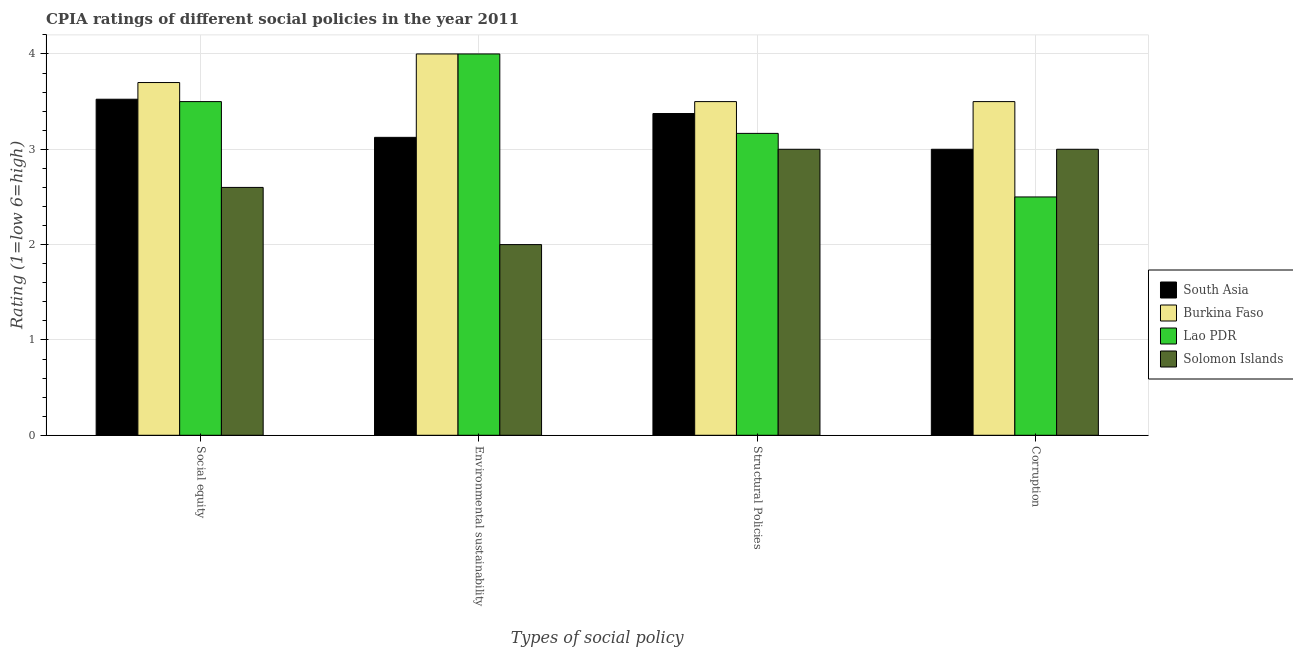How many different coloured bars are there?
Offer a terse response. 4. How many groups of bars are there?
Offer a terse response. 4. What is the label of the 2nd group of bars from the left?
Your response must be concise. Environmental sustainability. What is the cpia rating of structural policies in Lao PDR?
Ensure brevity in your answer.  3.17. Across all countries, what is the minimum cpia rating of environmental sustainability?
Your answer should be very brief. 2. In which country was the cpia rating of structural policies maximum?
Keep it short and to the point. Burkina Faso. In which country was the cpia rating of structural policies minimum?
Keep it short and to the point. Solomon Islands. What is the total cpia rating of social equity in the graph?
Provide a succinct answer. 13.32. What is the difference between the cpia rating of social equity in Lao PDR and that in Solomon Islands?
Give a very brief answer. 0.9. What is the difference between the cpia rating of environmental sustainability in Solomon Islands and the cpia rating of structural policies in South Asia?
Make the answer very short. -1.38. What is the average cpia rating of environmental sustainability per country?
Make the answer very short. 3.28. What is the difference between the cpia rating of environmental sustainability and cpia rating of corruption in Solomon Islands?
Offer a very short reply. -1. In how many countries, is the cpia rating of structural policies greater than 2.6 ?
Keep it short and to the point. 4. What is the ratio of the cpia rating of structural policies in Lao PDR to that in South Asia?
Provide a succinct answer. 0.94. Is the cpia rating of environmental sustainability in Lao PDR less than that in Solomon Islands?
Your answer should be very brief. No. What is the difference between the highest and the second highest cpia rating of social equity?
Your answer should be compact. 0.18. In how many countries, is the cpia rating of structural policies greater than the average cpia rating of structural policies taken over all countries?
Offer a terse response. 2. What does the 4th bar from the left in Environmental sustainability represents?
Your answer should be compact. Solomon Islands. What does the 4th bar from the right in Environmental sustainability represents?
Make the answer very short. South Asia. Are all the bars in the graph horizontal?
Give a very brief answer. No. What is the difference between two consecutive major ticks on the Y-axis?
Keep it short and to the point. 1. Where does the legend appear in the graph?
Your response must be concise. Center right. How many legend labels are there?
Offer a terse response. 4. What is the title of the graph?
Your answer should be compact. CPIA ratings of different social policies in the year 2011. What is the label or title of the X-axis?
Your response must be concise. Types of social policy. What is the label or title of the Y-axis?
Offer a very short reply. Rating (1=low 6=high). What is the Rating (1=low 6=high) of South Asia in Social equity?
Your response must be concise. 3.52. What is the Rating (1=low 6=high) in Burkina Faso in Social equity?
Ensure brevity in your answer.  3.7. What is the Rating (1=low 6=high) in Solomon Islands in Social equity?
Offer a very short reply. 2.6. What is the Rating (1=low 6=high) of South Asia in Environmental sustainability?
Your answer should be very brief. 3.12. What is the Rating (1=low 6=high) of South Asia in Structural Policies?
Ensure brevity in your answer.  3.38. What is the Rating (1=low 6=high) of Burkina Faso in Structural Policies?
Make the answer very short. 3.5. What is the Rating (1=low 6=high) of Lao PDR in Structural Policies?
Provide a short and direct response. 3.17. What is the Rating (1=low 6=high) of Burkina Faso in Corruption?
Your answer should be very brief. 3.5. What is the Rating (1=low 6=high) in Solomon Islands in Corruption?
Provide a succinct answer. 3. Across all Types of social policy, what is the maximum Rating (1=low 6=high) in South Asia?
Offer a terse response. 3.52. Across all Types of social policy, what is the maximum Rating (1=low 6=high) of Solomon Islands?
Your answer should be compact. 3. Across all Types of social policy, what is the minimum Rating (1=low 6=high) of Lao PDR?
Ensure brevity in your answer.  2.5. Across all Types of social policy, what is the minimum Rating (1=low 6=high) of Solomon Islands?
Keep it short and to the point. 2. What is the total Rating (1=low 6=high) in South Asia in the graph?
Provide a succinct answer. 13.03. What is the total Rating (1=low 6=high) in Lao PDR in the graph?
Your response must be concise. 13.17. What is the total Rating (1=low 6=high) of Solomon Islands in the graph?
Provide a short and direct response. 10.6. What is the difference between the Rating (1=low 6=high) in Burkina Faso in Social equity and that in Environmental sustainability?
Offer a very short reply. -0.3. What is the difference between the Rating (1=low 6=high) in South Asia in Social equity and that in Structural Policies?
Your response must be concise. 0.15. What is the difference between the Rating (1=low 6=high) of Solomon Islands in Social equity and that in Structural Policies?
Give a very brief answer. -0.4. What is the difference between the Rating (1=low 6=high) in South Asia in Social equity and that in Corruption?
Provide a succinct answer. 0.53. What is the difference between the Rating (1=low 6=high) of Lao PDR in Social equity and that in Corruption?
Provide a succinct answer. 1. What is the difference between the Rating (1=low 6=high) of Solomon Islands in Social equity and that in Corruption?
Ensure brevity in your answer.  -0.4. What is the difference between the Rating (1=low 6=high) in Burkina Faso in Environmental sustainability and that in Structural Policies?
Offer a terse response. 0.5. What is the difference between the Rating (1=low 6=high) of Lao PDR in Environmental sustainability and that in Structural Policies?
Provide a short and direct response. 0.83. What is the difference between the Rating (1=low 6=high) of South Asia in Environmental sustainability and that in Corruption?
Provide a succinct answer. 0.12. What is the difference between the Rating (1=low 6=high) of Burkina Faso in Environmental sustainability and that in Corruption?
Provide a short and direct response. 0.5. What is the difference between the Rating (1=low 6=high) of Solomon Islands in Environmental sustainability and that in Corruption?
Offer a terse response. -1. What is the difference between the Rating (1=low 6=high) of South Asia in Structural Policies and that in Corruption?
Provide a short and direct response. 0.38. What is the difference between the Rating (1=low 6=high) in Burkina Faso in Structural Policies and that in Corruption?
Ensure brevity in your answer.  0. What is the difference between the Rating (1=low 6=high) in Solomon Islands in Structural Policies and that in Corruption?
Your answer should be very brief. 0. What is the difference between the Rating (1=low 6=high) in South Asia in Social equity and the Rating (1=low 6=high) in Burkina Faso in Environmental sustainability?
Keep it short and to the point. -0.47. What is the difference between the Rating (1=low 6=high) in South Asia in Social equity and the Rating (1=low 6=high) in Lao PDR in Environmental sustainability?
Keep it short and to the point. -0.47. What is the difference between the Rating (1=low 6=high) in South Asia in Social equity and the Rating (1=low 6=high) in Solomon Islands in Environmental sustainability?
Offer a terse response. 1.52. What is the difference between the Rating (1=low 6=high) in Burkina Faso in Social equity and the Rating (1=low 6=high) in Lao PDR in Environmental sustainability?
Provide a succinct answer. -0.3. What is the difference between the Rating (1=low 6=high) in Burkina Faso in Social equity and the Rating (1=low 6=high) in Solomon Islands in Environmental sustainability?
Make the answer very short. 1.7. What is the difference between the Rating (1=low 6=high) of Lao PDR in Social equity and the Rating (1=low 6=high) of Solomon Islands in Environmental sustainability?
Offer a very short reply. 1.5. What is the difference between the Rating (1=low 6=high) in South Asia in Social equity and the Rating (1=low 6=high) in Burkina Faso in Structural Policies?
Make the answer very short. 0.03. What is the difference between the Rating (1=low 6=high) of South Asia in Social equity and the Rating (1=low 6=high) of Lao PDR in Structural Policies?
Keep it short and to the point. 0.36. What is the difference between the Rating (1=low 6=high) in South Asia in Social equity and the Rating (1=low 6=high) in Solomon Islands in Structural Policies?
Make the answer very short. 0.53. What is the difference between the Rating (1=low 6=high) in Burkina Faso in Social equity and the Rating (1=low 6=high) in Lao PDR in Structural Policies?
Give a very brief answer. 0.53. What is the difference between the Rating (1=low 6=high) in South Asia in Social equity and the Rating (1=low 6=high) in Burkina Faso in Corruption?
Provide a short and direct response. 0.03. What is the difference between the Rating (1=low 6=high) in South Asia in Social equity and the Rating (1=low 6=high) in Solomon Islands in Corruption?
Your response must be concise. 0.53. What is the difference between the Rating (1=low 6=high) in Lao PDR in Social equity and the Rating (1=low 6=high) in Solomon Islands in Corruption?
Your answer should be very brief. 0.5. What is the difference between the Rating (1=low 6=high) of South Asia in Environmental sustainability and the Rating (1=low 6=high) of Burkina Faso in Structural Policies?
Keep it short and to the point. -0.38. What is the difference between the Rating (1=low 6=high) of South Asia in Environmental sustainability and the Rating (1=low 6=high) of Lao PDR in Structural Policies?
Offer a terse response. -0.04. What is the difference between the Rating (1=low 6=high) of South Asia in Environmental sustainability and the Rating (1=low 6=high) of Solomon Islands in Structural Policies?
Ensure brevity in your answer.  0.12. What is the difference between the Rating (1=low 6=high) in Burkina Faso in Environmental sustainability and the Rating (1=low 6=high) in Solomon Islands in Structural Policies?
Make the answer very short. 1. What is the difference between the Rating (1=low 6=high) in South Asia in Environmental sustainability and the Rating (1=low 6=high) in Burkina Faso in Corruption?
Give a very brief answer. -0.38. What is the difference between the Rating (1=low 6=high) in South Asia in Environmental sustainability and the Rating (1=low 6=high) in Lao PDR in Corruption?
Give a very brief answer. 0.62. What is the difference between the Rating (1=low 6=high) in Burkina Faso in Environmental sustainability and the Rating (1=low 6=high) in Solomon Islands in Corruption?
Keep it short and to the point. 1. What is the difference between the Rating (1=low 6=high) in South Asia in Structural Policies and the Rating (1=low 6=high) in Burkina Faso in Corruption?
Provide a succinct answer. -0.12. What is the difference between the Rating (1=low 6=high) of Burkina Faso in Structural Policies and the Rating (1=low 6=high) of Solomon Islands in Corruption?
Give a very brief answer. 0.5. What is the difference between the Rating (1=low 6=high) in Lao PDR in Structural Policies and the Rating (1=low 6=high) in Solomon Islands in Corruption?
Give a very brief answer. 0.17. What is the average Rating (1=low 6=high) in South Asia per Types of social policy?
Provide a succinct answer. 3.26. What is the average Rating (1=low 6=high) of Burkina Faso per Types of social policy?
Your response must be concise. 3.67. What is the average Rating (1=low 6=high) in Lao PDR per Types of social policy?
Provide a succinct answer. 3.29. What is the average Rating (1=low 6=high) in Solomon Islands per Types of social policy?
Your response must be concise. 2.65. What is the difference between the Rating (1=low 6=high) of South Asia and Rating (1=low 6=high) of Burkina Faso in Social equity?
Give a very brief answer. -0.17. What is the difference between the Rating (1=low 6=high) of South Asia and Rating (1=low 6=high) of Lao PDR in Social equity?
Give a very brief answer. 0.03. What is the difference between the Rating (1=low 6=high) of South Asia and Rating (1=low 6=high) of Solomon Islands in Social equity?
Give a very brief answer. 0.93. What is the difference between the Rating (1=low 6=high) of Burkina Faso and Rating (1=low 6=high) of Solomon Islands in Social equity?
Give a very brief answer. 1.1. What is the difference between the Rating (1=low 6=high) of South Asia and Rating (1=low 6=high) of Burkina Faso in Environmental sustainability?
Your response must be concise. -0.88. What is the difference between the Rating (1=low 6=high) in South Asia and Rating (1=low 6=high) in Lao PDR in Environmental sustainability?
Your answer should be compact. -0.88. What is the difference between the Rating (1=low 6=high) in South Asia and Rating (1=low 6=high) in Solomon Islands in Environmental sustainability?
Your answer should be compact. 1.12. What is the difference between the Rating (1=low 6=high) in South Asia and Rating (1=low 6=high) in Burkina Faso in Structural Policies?
Provide a succinct answer. -0.12. What is the difference between the Rating (1=low 6=high) in South Asia and Rating (1=low 6=high) in Lao PDR in Structural Policies?
Keep it short and to the point. 0.21. What is the difference between the Rating (1=low 6=high) of South Asia and Rating (1=low 6=high) of Solomon Islands in Structural Policies?
Offer a terse response. 0.38. What is the difference between the Rating (1=low 6=high) of Burkina Faso and Rating (1=low 6=high) of Lao PDR in Structural Policies?
Give a very brief answer. 0.33. What is the difference between the Rating (1=low 6=high) of South Asia and Rating (1=low 6=high) of Burkina Faso in Corruption?
Ensure brevity in your answer.  -0.5. What is the difference between the Rating (1=low 6=high) in South Asia and Rating (1=low 6=high) in Lao PDR in Corruption?
Ensure brevity in your answer.  0.5. What is the difference between the Rating (1=low 6=high) of South Asia and Rating (1=low 6=high) of Solomon Islands in Corruption?
Provide a short and direct response. 0. What is the difference between the Rating (1=low 6=high) in Lao PDR and Rating (1=low 6=high) in Solomon Islands in Corruption?
Make the answer very short. -0.5. What is the ratio of the Rating (1=low 6=high) in South Asia in Social equity to that in Environmental sustainability?
Offer a very short reply. 1.13. What is the ratio of the Rating (1=low 6=high) of Burkina Faso in Social equity to that in Environmental sustainability?
Offer a terse response. 0.93. What is the ratio of the Rating (1=low 6=high) of South Asia in Social equity to that in Structural Policies?
Offer a very short reply. 1.04. What is the ratio of the Rating (1=low 6=high) in Burkina Faso in Social equity to that in Structural Policies?
Provide a succinct answer. 1.06. What is the ratio of the Rating (1=low 6=high) of Lao PDR in Social equity to that in Structural Policies?
Your answer should be very brief. 1.11. What is the ratio of the Rating (1=low 6=high) in Solomon Islands in Social equity to that in Structural Policies?
Your answer should be very brief. 0.87. What is the ratio of the Rating (1=low 6=high) of South Asia in Social equity to that in Corruption?
Offer a terse response. 1.18. What is the ratio of the Rating (1=low 6=high) of Burkina Faso in Social equity to that in Corruption?
Make the answer very short. 1.06. What is the ratio of the Rating (1=low 6=high) in Solomon Islands in Social equity to that in Corruption?
Keep it short and to the point. 0.87. What is the ratio of the Rating (1=low 6=high) of South Asia in Environmental sustainability to that in Structural Policies?
Your response must be concise. 0.93. What is the ratio of the Rating (1=low 6=high) in Lao PDR in Environmental sustainability to that in Structural Policies?
Give a very brief answer. 1.26. What is the ratio of the Rating (1=low 6=high) of South Asia in Environmental sustainability to that in Corruption?
Offer a very short reply. 1.04. What is the ratio of the Rating (1=low 6=high) in Burkina Faso in Environmental sustainability to that in Corruption?
Make the answer very short. 1.14. What is the ratio of the Rating (1=low 6=high) of Lao PDR in Environmental sustainability to that in Corruption?
Provide a short and direct response. 1.6. What is the ratio of the Rating (1=low 6=high) in Burkina Faso in Structural Policies to that in Corruption?
Ensure brevity in your answer.  1. What is the ratio of the Rating (1=low 6=high) of Lao PDR in Structural Policies to that in Corruption?
Your answer should be very brief. 1.27. What is the ratio of the Rating (1=low 6=high) of Solomon Islands in Structural Policies to that in Corruption?
Your answer should be very brief. 1. What is the difference between the highest and the second highest Rating (1=low 6=high) of Solomon Islands?
Offer a very short reply. 0. What is the difference between the highest and the lowest Rating (1=low 6=high) in South Asia?
Keep it short and to the point. 0.53. What is the difference between the highest and the lowest Rating (1=low 6=high) in Lao PDR?
Provide a succinct answer. 1.5. 